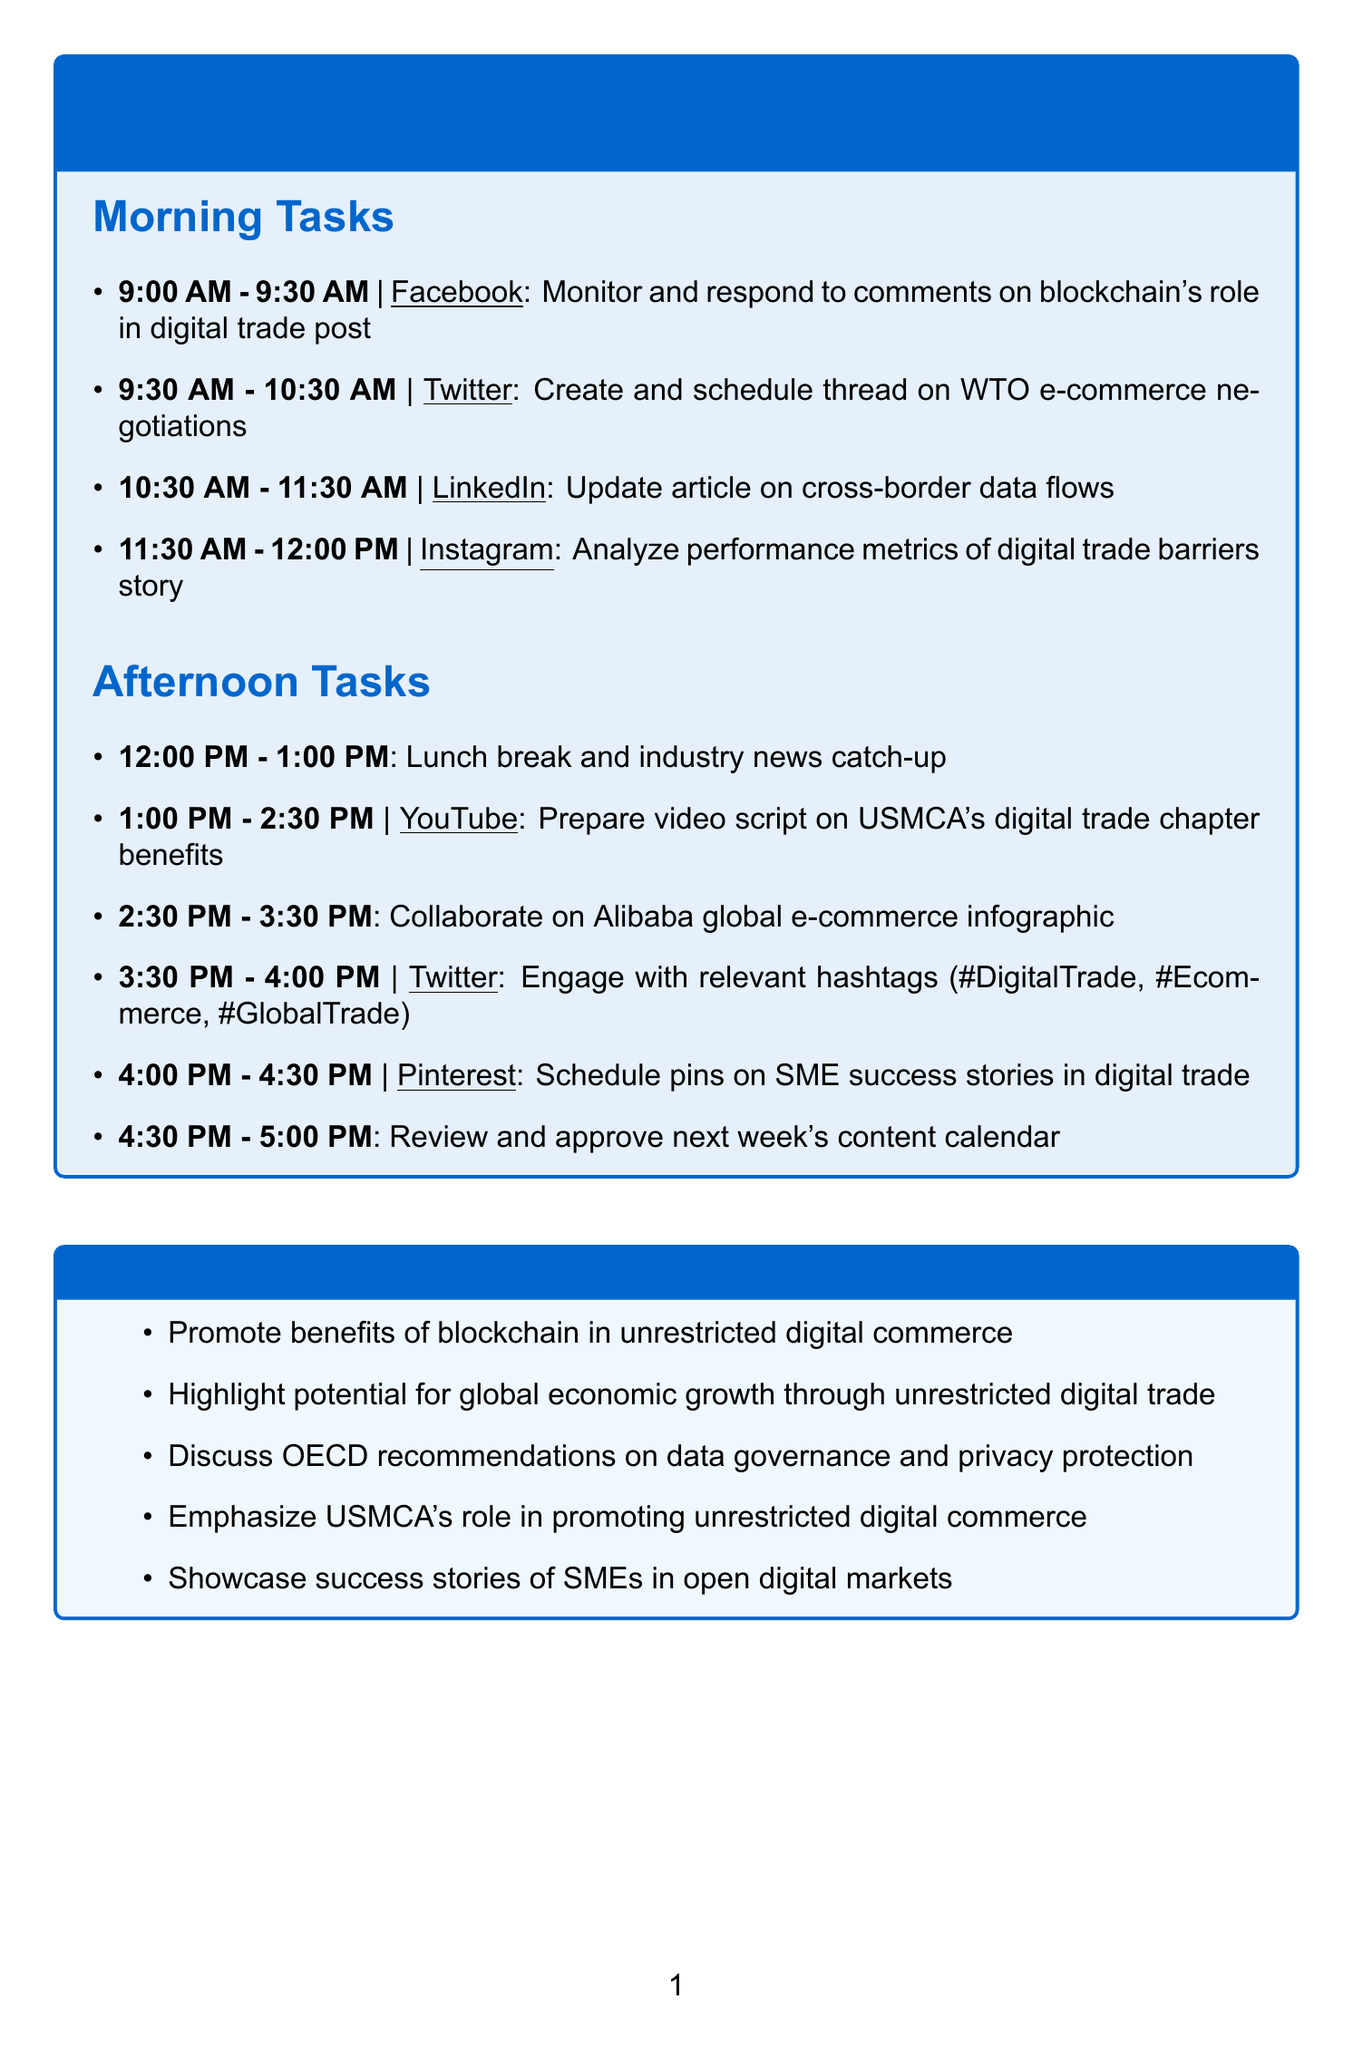What time is the lunch break scheduled? The lunch break is scheduled from 12:00 PM to 1:00 PM.
Answer: 12:00 PM - 1:00 PM Which platform is used for analyzing performance metrics? The performance metrics are analyzed on Instagram.
Answer: Instagram What is the first task of the day? The first task is to monitor and respond to comments on Facebook.
Answer: Monitor and respond to comments on Facebook post about blockchain's role in digital trade How long is the task for preparing the YouTube video script? The task for preparing the YouTube video script lasts 1.5 hours, from 1:00 PM to 2:30 PM.
Answer: 1.5 hours What are the relevant hashtags used in the Twitter engagement task? The relevant hashtags mentioned for Twitter engagement are #DigitalTrade, #Ecommerce, and #GlobalTrade.
Answer: #DigitalTrade, #Ecommerce, #GlobalTrade What is the main purpose of updating the LinkedIn article? The main purpose is to include recent OECD recommendations on data governance and privacy protection in digital trade.
Answer: Include recent OECD recommendations on data governance and privacy protection How many tasks are scheduled for the morning? There are four tasks listed for the morning.
Answer: Four What type of content is being created for Pinterest? The content being created for Pinterest showcases success stories of SMEs in unrestricted digital trade.
Answer: Success stories of SMEs in unrestricted digital trade 